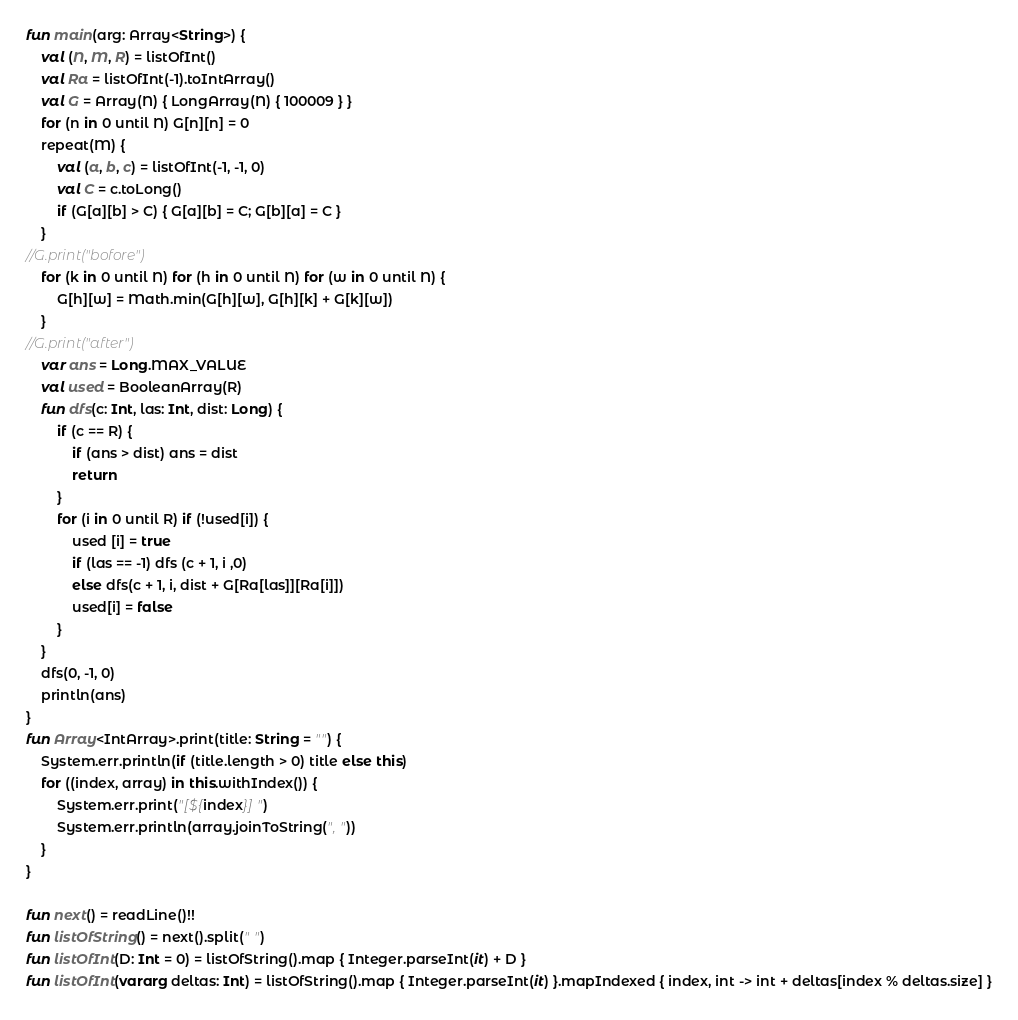<code> <loc_0><loc_0><loc_500><loc_500><_Kotlin_>fun main(arg: Array<String>) {
    val (N, M, R) = listOfInt()
    val Ra = listOfInt(-1).toIntArray()
    val G = Array(N) { LongArray(N) { 100009 } }
    for (n in 0 until N) G[n][n] = 0
    repeat(M) {
        val (a, b, c) = listOfInt(-1, -1, 0)
        val C = c.toLong()
        if (G[a][b] > C) { G[a][b] = C; G[b][a] = C }
    }
//G.print("bofore")
    for (k in 0 until N) for (h in 0 until N) for (w in 0 until N) {
        G[h][w] = Math.min(G[h][w], G[h][k] + G[k][w])
    }
//G.print("after")
    var ans = Long.MAX_VALUE
    val used = BooleanArray(R)
    fun dfs(c: Int, las: Int, dist: Long) {
        if (c == R) {
            if (ans > dist) ans = dist
            return
        }
        for (i in 0 until R) if (!used[i]) {
            used [i] = true
            if (las == -1) dfs (c + 1, i ,0)
            else dfs(c + 1, i, dist + G[Ra[las]][Ra[i]])
            used[i] = false
        }
    }
    dfs(0, -1, 0)
    println(ans)
}
fun Array<IntArray>.print(title: String = "") {
    System.err.println(if (title.length > 0) title else this)
    for ((index, array) in this.withIndex()) {
        System.err.print("[${index}] ")
        System.err.println(array.joinToString(", "))
    }
}

fun next() = readLine()!!
fun listOfString() = next().split(" ")
fun listOfInt(D: Int = 0) = listOfString().map { Integer.parseInt(it) + D }
fun listOfInt(vararg deltas: Int) = listOfString().map { Integer.parseInt(it) }.mapIndexed { index, int -> int + deltas[index % deltas.size] }
</code> 